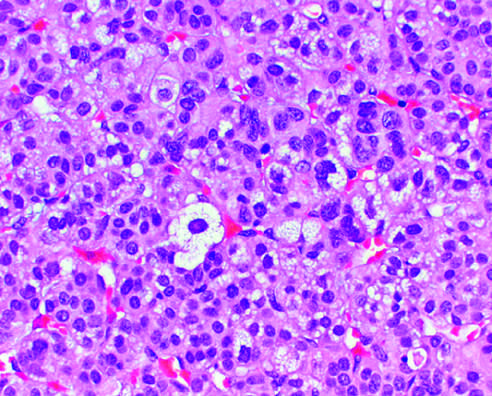re gram-positive, elongated cocci in pairs and short chains and a neutrophil vacuolated because of the presence of intracytoplasmic lipid?
Answer the question using a single word or phrase. No 